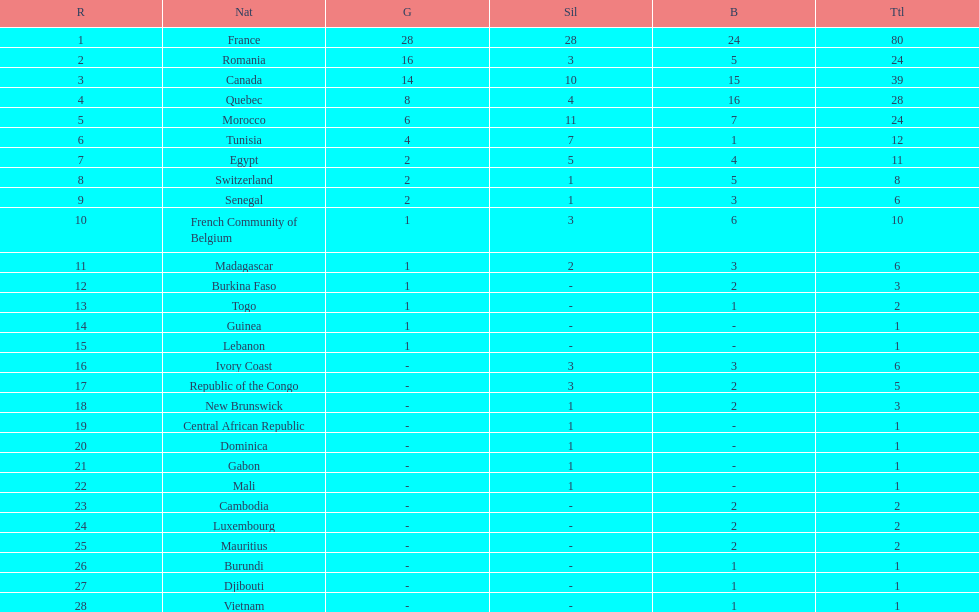How many nations won at least 10 medals? 8. 